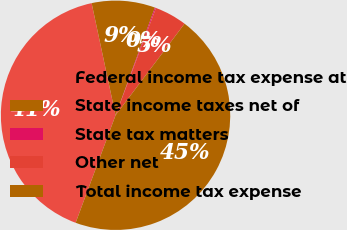Convert chart to OTSL. <chart><loc_0><loc_0><loc_500><loc_500><pie_chart><fcel>Federal income tax expense at<fcel>State income taxes net of<fcel>State tax matters<fcel>Other net<fcel>Total income tax expense<nl><fcel>40.99%<fcel>8.93%<fcel>0.15%<fcel>4.54%<fcel>45.38%<nl></chart> 